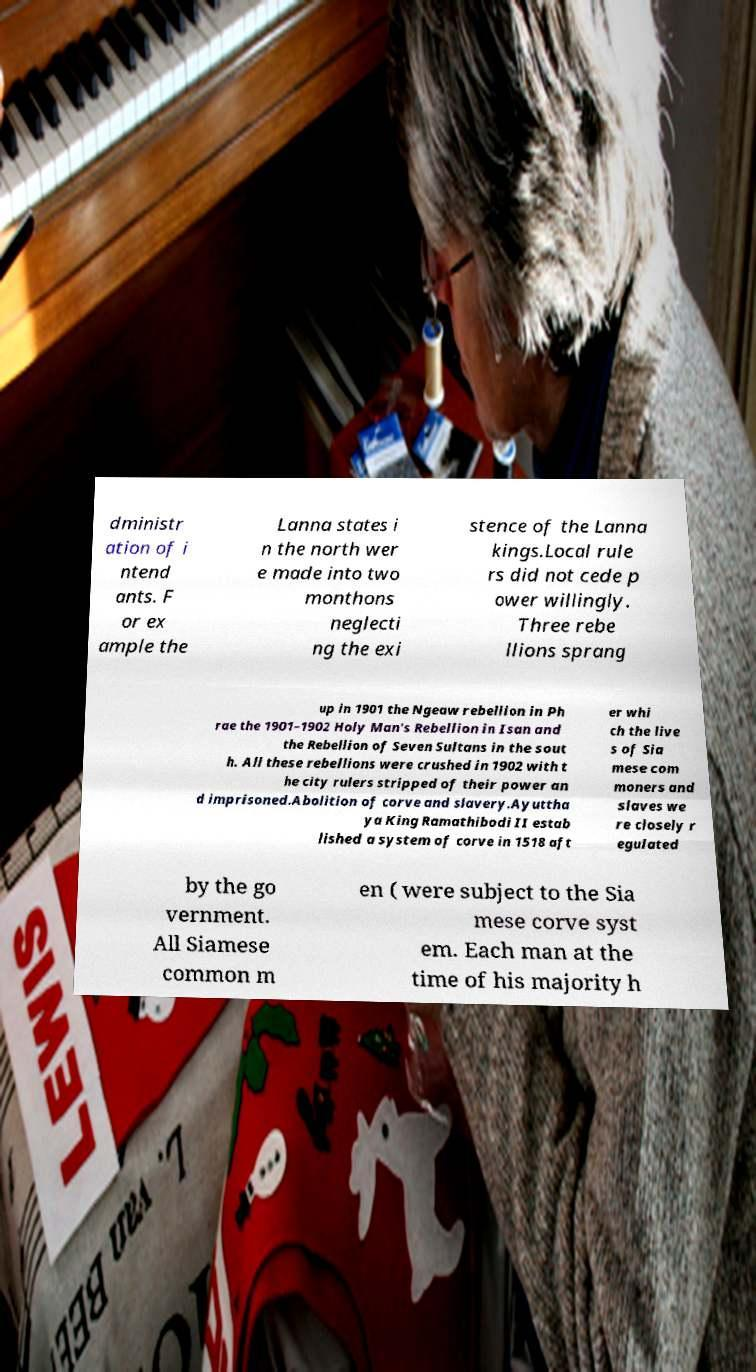Can you accurately transcribe the text from the provided image for me? dministr ation of i ntend ants. F or ex ample the Lanna states i n the north wer e made into two monthons neglecti ng the exi stence of the Lanna kings.Local rule rs did not cede p ower willingly. Three rebe llions sprang up in 1901 the Ngeaw rebellion in Ph rae the 1901–1902 Holy Man's Rebellion in Isan and the Rebellion of Seven Sultans in the sout h. All these rebellions were crushed in 1902 with t he city rulers stripped of their power an d imprisoned.Abolition of corve and slavery.Ayuttha ya King Ramathibodi II estab lished a system of corve in 1518 aft er whi ch the live s of Sia mese com moners and slaves we re closely r egulated by the go vernment. All Siamese common m en ( were subject to the Sia mese corve syst em. Each man at the time of his majority h 